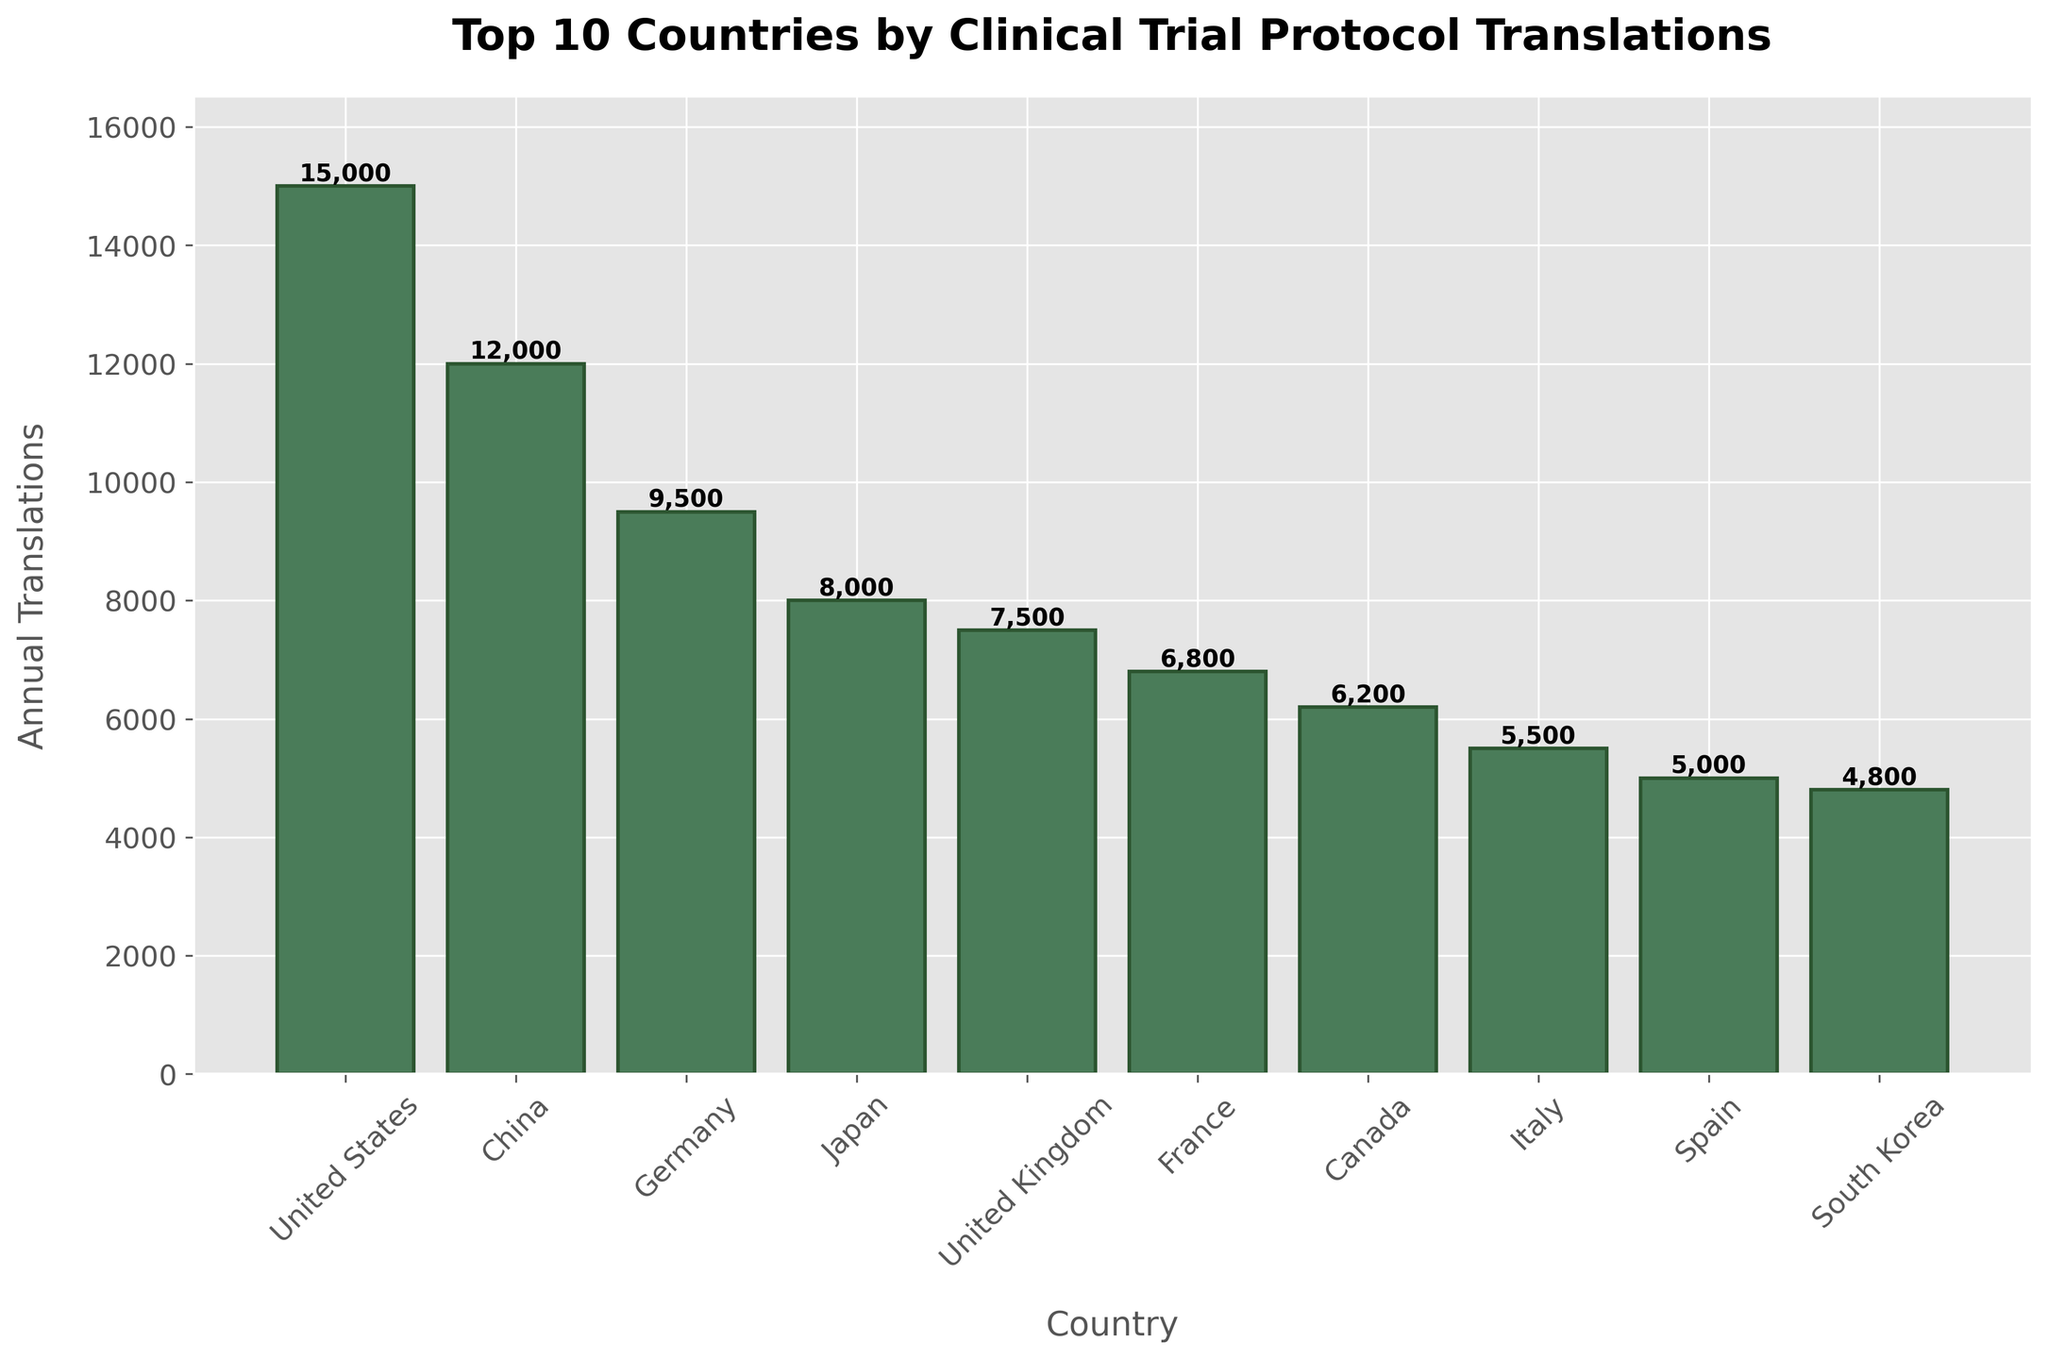Which country has the highest number of annual clinical trial protocol translations? The bar chart shows the United States has the tallest bar, indicating the highest number of annual clinical trial protocol translations.
Answer: United States How many more annual clinical trial protocol translations does the United States have compared to Spain? The chart shows the United States has 15,000 translations and Spain has 5,000 translations. Subtracting the two values: 15,000 - 5,000 = 10,000.
Answer: 10,000 Which countries have fewer annual clinical trial protocol translations than Japan but more than Canada? From the chart, Japan has 8,000 translations and Canada has 6,200 translations. Countries within this range are United Kingdom (7,500) and France (6,800).
Answer: United Kingdom, France What is the combined total of annual clinical trial protocol translations for Germany and Italy? Germany has 9,500 translations and Italy has 5,500 translations. Adding the two values: 9,500 + 5,500 = 15,000.
Answer: 15,000 What is the difference in the number of translations between the country with the second highest translations and the third highest? The chart shows China with 12,000 translations and Germany with 9,500 translations. Subtracting the two values: 12,000 - 9,500 = 2,500.
Answer: 2,500 Which country translates 7,500 clinical trial protocols annually? The chart shows the country with 7,500 translations labeled as the United Kingdom.
Answer: United Kingdom What is the average number of annual clinical trial protocol translations for the top 5 countries? The top 5 countries and their translations are: United States (15,000), China (12,000), Germany (9,500), Japan (8,000), United Kingdom (7,500). Sum these values: 15,000 + 12,000 + 9,500 + 8,000 + 7,500 = 52,000. The average is 52,000 / 5 = 10,400.
Answer: 10,400 By how much does the number of annual clinical trial protocol translations for France exceed that for South Korea? France has 6,800 translations and South Korea has 4,800 translations. The difference is 6,800 - 4,800 = 2,000.
Answer: 2,000 Which country is ranked 10th in terms of annual clinical trial protocol translations? According to the chart, South Korea is the country with the 10th highest number of annual clinical trial protocol translations.
Answer: South Korea 